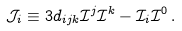<formula> <loc_0><loc_0><loc_500><loc_500>\mathcal { J } _ { i } \equiv 3 d _ { i j k } \mathcal { I } ^ { j } \mathcal { I } ^ { k } - \mathcal { I } _ { i } \mathcal { I } ^ { 0 } \, .</formula> 